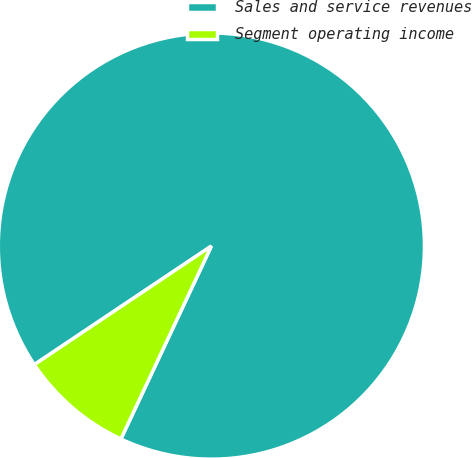<chart> <loc_0><loc_0><loc_500><loc_500><pie_chart><fcel>Sales and service revenues<fcel>Segment operating income<nl><fcel>91.37%<fcel>8.63%<nl></chart> 